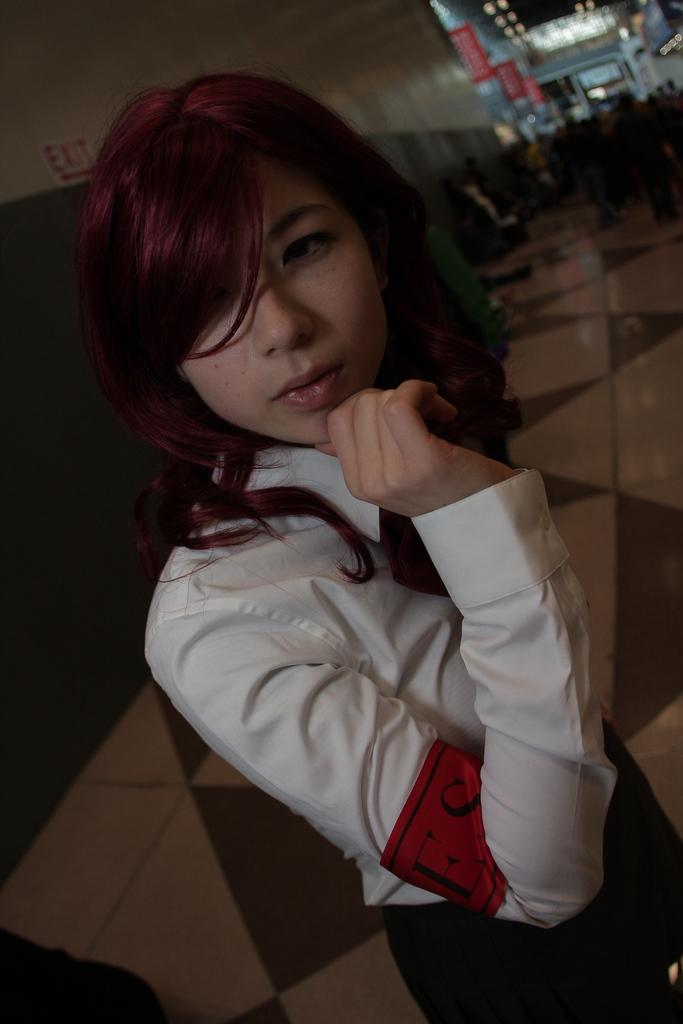Who is present in the image? There is a woman in the image. What is the woman doing in the image? The woman is standing on the floor. What can be seen behind the woman in the image? There is a wall visible in the image. Can you see any corks floating in the sea in the image? There is no sea or corks present in the image; it features a woman standing on the floor with a wall visible in the background. 